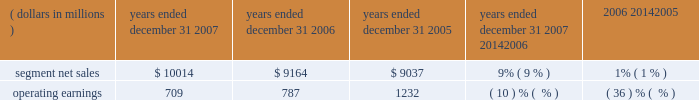Unit shipments increased 49% ( 49 % ) to 217.4 million units in 2006 , compared to 146.0 million units in 2005 .
The overall increase was driven by increased unit shipments of products for gsm , cdma and 3g technologies , partially offset by decreased unit shipments of products for iden technology .
For the full year 2006 , unit shipments by the segment increased in all regions .
Due to the segment 2019s increase in unit shipments outpacing overall growth in the worldwide handset market , which grew approximately 20% ( 20 % ) in 2006 , the segment believes that it expanded its global handset market share to an estimated 22% ( 22 % ) for the full year 2006 .
In 2006 , asp decreased approximately 11% ( 11 % ) compared to 2005 .
The overall decrease in asp was driven primarily by changes in the geographic and product-tier mix of sales .
By comparison , asp decreased approximately 10% ( 10 % ) in 2005 and increased approximately 15% ( 15 % ) in 2004 .
Asp is impacted by numerous factors , including product mix , market conditions and competitive product offerings , and asp trends often vary over time .
In 2006 , the largest of the segment 2019s end customers ( including sales through distributors ) were china mobile , verizon , sprint nextel , cingular , and t-mobile .
These five largest customers accounted for approximately 39% ( 39 % ) of the segment 2019s net sales in 2006 .
Besides selling directly to carriers and operators , the segment also sold products through a variety of third-party distributors and retailers , which accounted for approximately 38% ( 38 % ) of the segment 2019s net sales .
The largest of these distributors was brightstar corporation .
Although the u.s .
Market continued to be the segment 2019s largest individual market , many of our customers , and more than 65% ( 65 % ) of the segment 2019s 2006 net sales , were outside the u.s .
The largest of these international markets were china , brazil , the united kingdom and mexico .
Home and networks mobility segment the home and networks mobility segment designs , manufactures , sells , installs and services : ( i ) digital video , internet protocol ( 201cip 201d ) video and broadcast network interactive set-tops ( 201cdigital entertainment devices 201d ) , end-to- end video delivery solutions , broadband access infrastructure systems , and associated data and voice customer premise equipment ( 201cbroadband gateways 201d ) to cable television and telecom service providers ( collectively , referred to as the 201chome business 201d ) , and ( ii ) wireless access systems ( 201cwireless networks 201d ) , including cellular infrastructure systems and wireless broadband systems , to wireless service providers .
In 2007 , the segment 2019s net sales represented 27% ( 27 % ) of the company 2019s consolidated net sales , compared to 21% ( 21 % ) in 2006 and 26% ( 26 % ) in 2005 .
( dollars in millions ) 2007 2006 2005 2007 20142006 2006 20142005 years ended december 31 percent change .
Segment results 20142007 compared to 2006 in 2007 , the segment 2019s net sales increased 9% ( 9 % ) to $ 10.0 billion , compared to $ 9.2 billion in 2006 .
The 9% ( 9 % ) increase in net sales reflects a 27% ( 27 % ) increase in net sales in the home business , partially offset by a 1% ( 1 % ) decrease in net sales of wireless networks .
Net sales of digital entertainment devices increased approximately 43% ( 43 % ) , reflecting increased demand for digital set-tops , including hd/dvr set-tops and ip set-tops , partially offset by a decline in asp due to a product mix shift towards all-digital set-tops .
Unit shipments of digital entertainment devices increased 51% ( 51 % ) to 15.2 million units .
Net sales of broadband gateways increased approximately 6% ( 6 % ) , primarily due to higher net sales of data modems , driven by net sales from the netopia business acquired in february 2007 .
Net sales of wireless networks decreased 1% ( 1 % ) , primarily driven by lower net sales of iden and cdma infrastructure equipment , partially offset by higher net sales of gsm infrastructure equipment , despite competitive pricing pressure .
On a geographic basis , the 9% ( 9 % ) increase in net sales reflects higher net sales in all geographic regions .
The increase in net sales in north america was driven primarily by higher sales of digital entertainment devices , partially offset by lower net sales of iden and cdma infrastructure equipment .
The increase in net sales in asia was primarily due to higher net sales of gsm infrastructure equipment , partially offset by lower net sales of cdma infrastructure equipment .
The increase in net sales in emea was , primarily due to higher net sales of gsm infrastructure equipment , partially offset by lower demand for iden and cdma infrastructure equipment .
Net sales in north america continue to comprise a significant portion of the segment 2019s business , accounting for 52% ( 52 % ) of the segment 2019s total net sales in 2007 , compared to 56% ( 56 % ) of the segment 2019s total net sales in 2006 .
60 management 2019s discussion and analysis of financial condition and results of operations .
What was the percentage change in the operating earnings from 2005 to 2007? 
Computations: ((709 - 1232) / 1232)
Answer: -0.42451. 